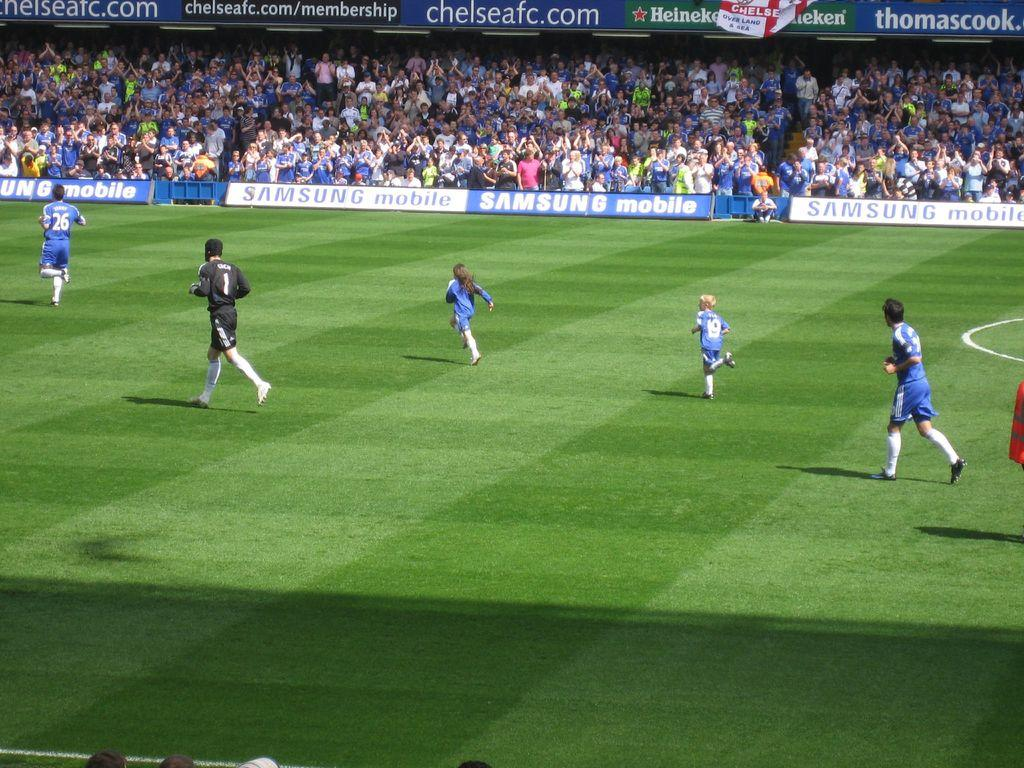<image>
Offer a succinct explanation of the picture presented. A large soccer stadium is sponsored by Samsung Mobile. 